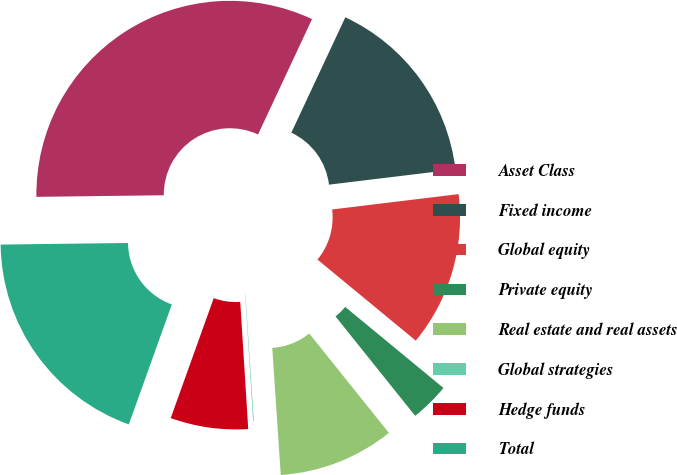Convert chart. <chart><loc_0><loc_0><loc_500><loc_500><pie_chart><fcel>Asset Class<fcel>Fixed income<fcel>Global equity<fcel>Private equity<fcel>Real estate and real assets<fcel>Global strategies<fcel>Hedge funds<fcel>Total<nl><fcel>32.16%<fcel>16.11%<fcel>12.9%<fcel>3.27%<fcel>9.69%<fcel>0.06%<fcel>6.48%<fcel>19.32%<nl></chart> 